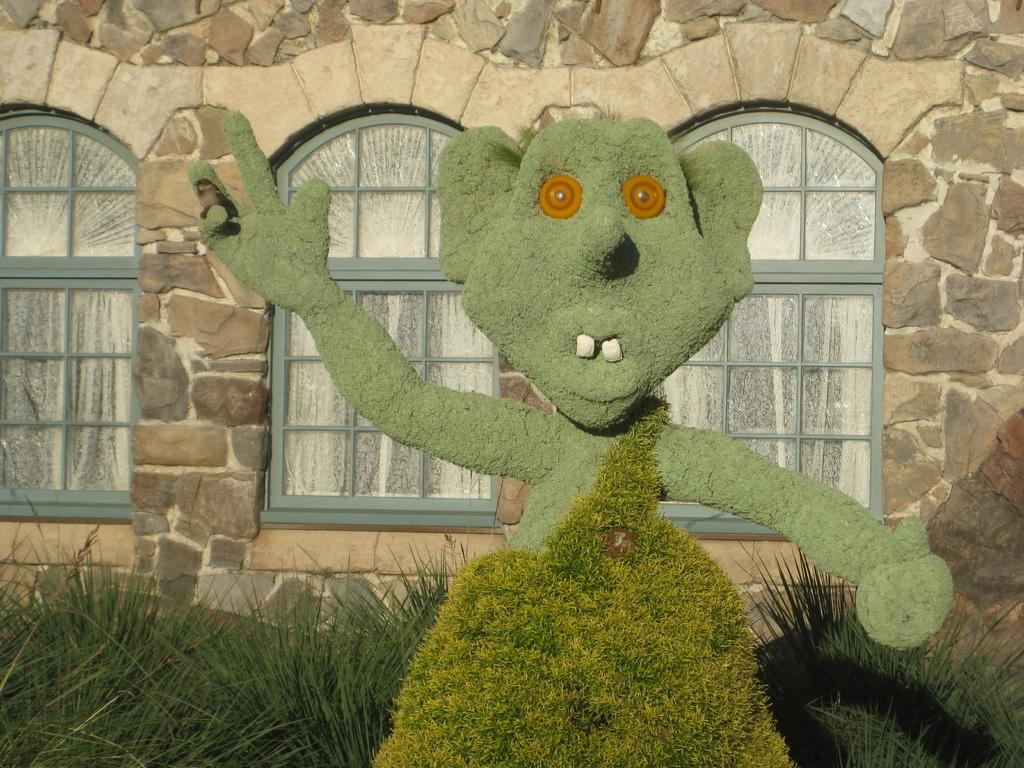What object in the image has a plant growing on it? A toy in the image has a plant growing on it. What else can be seen on the toy? There is a bird on the toy's hands. What can be seen in the background of the image? There are plants and a building with a brick wall and windows in the background of the image. What type of cream can be seen in the jar on the toy's head? There is no jar or cream present on the toy's head in the image. 